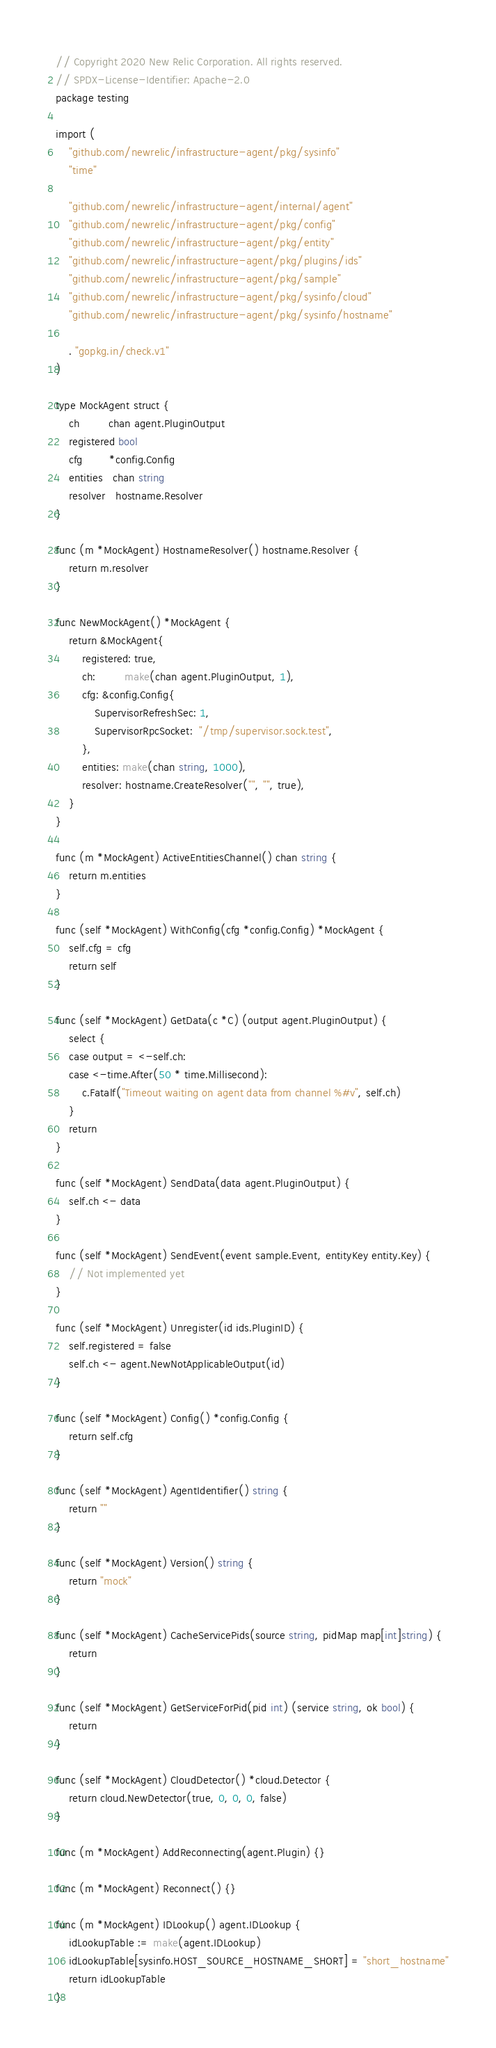<code> <loc_0><loc_0><loc_500><loc_500><_Go_>// Copyright 2020 New Relic Corporation. All rights reserved.
// SPDX-License-Identifier: Apache-2.0
package testing

import (
	"github.com/newrelic/infrastructure-agent/pkg/sysinfo"
	"time"

	"github.com/newrelic/infrastructure-agent/internal/agent"
	"github.com/newrelic/infrastructure-agent/pkg/config"
	"github.com/newrelic/infrastructure-agent/pkg/entity"
	"github.com/newrelic/infrastructure-agent/pkg/plugins/ids"
	"github.com/newrelic/infrastructure-agent/pkg/sample"
	"github.com/newrelic/infrastructure-agent/pkg/sysinfo/cloud"
	"github.com/newrelic/infrastructure-agent/pkg/sysinfo/hostname"

	. "gopkg.in/check.v1"
)

type MockAgent struct {
	ch         chan agent.PluginOutput
	registered bool
	cfg        *config.Config
	entities   chan string
	resolver   hostname.Resolver
}

func (m *MockAgent) HostnameResolver() hostname.Resolver {
	return m.resolver
}

func NewMockAgent() *MockAgent {
	return &MockAgent{
		registered: true,
		ch:         make(chan agent.PluginOutput, 1),
		cfg: &config.Config{
			SupervisorRefreshSec: 1,
			SupervisorRpcSocket:  "/tmp/supervisor.sock.test",
		},
		entities: make(chan string, 1000),
		resolver: hostname.CreateResolver("", "", true),
	}
}

func (m *MockAgent) ActiveEntitiesChannel() chan string {
	return m.entities
}

func (self *MockAgent) WithConfig(cfg *config.Config) *MockAgent {
	self.cfg = cfg
	return self
}

func (self *MockAgent) GetData(c *C) (output agent.PluginOutput) {
	select {
	case output = <-self.ch:
	case <-time.After(50 * time.Millisecond):
		c.Fatalf("Timeout waiting on agent data from channel %#v", self.ch)
	}
	return
}

func (self *MockAgent) SendData(data agent.PluginOutput) {
	self.ch <- data
}

func (self *MockAgent) SendEvent(event sample.Event, entityKey entity.Key) {
	// Not implemented yet
}

func (self *MockAgent) Unregister(id ids.PluginID) {
	self.registered = false
	self.ch <- agent.NewNotApplicableOutput(id)
}

func (self *MockAgent) Config() *config.Config {
	return self.cfg
}

func (self *MockAgent) AgentIdentifier() string {
	return ""
}

func (self *MockAgent) Version() string {
	return "mock"
}

func (self *MockAgent) CacheServicePids(source string, pidMap map[int]string) {
	return
}

func (self *MockAgent) GetServiceForPid(pid int) (service string, ok bool) {
	return
}

func (self *MockAgent) CloudDetector() *cloud.Detector {
	return cloud.NewDetector(true, 0, 0, 0, false)
}

func (m *MockAgent) AddReconnecting(agent.Plugin) {}

func (m *MockAgent) Reconnect() {}

func (m *MockAgent) IDLookup() agent.IDLookup {
	idLookupTable := make(agent.IDLookup)
	idLookupTable[sysinfo.HOST_SOURCE_HOSTNAME_SHORT] = "short_hostname"
	return idLookupTable
}
</code> 